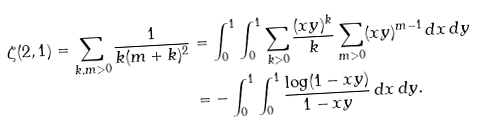<formula> <loc_0><loc_0><loc_500><loc_500>\zeta ( 2 , 1 ) = \sum _ { k , m > 0 } \frac { 1 } { k ( m + k ) ^ { 2 } } & = \int _ { 0 } ^ { 1 } \int _ { 0 } ^ { 1 } \sum _ { k > 0 } \frac { ( x y ) ^ { k } } { k } \sum _ { m > 0 } ( x y ) ^ { m - 1 } \, d x \, d y \\ & = - \int _ { 0 } ^ { 1 } \int _ { 0 } ^ { 1 } \frac { \log ( 1 - x y ) } { 1 - x y } \, d x \, d y .</formula> 